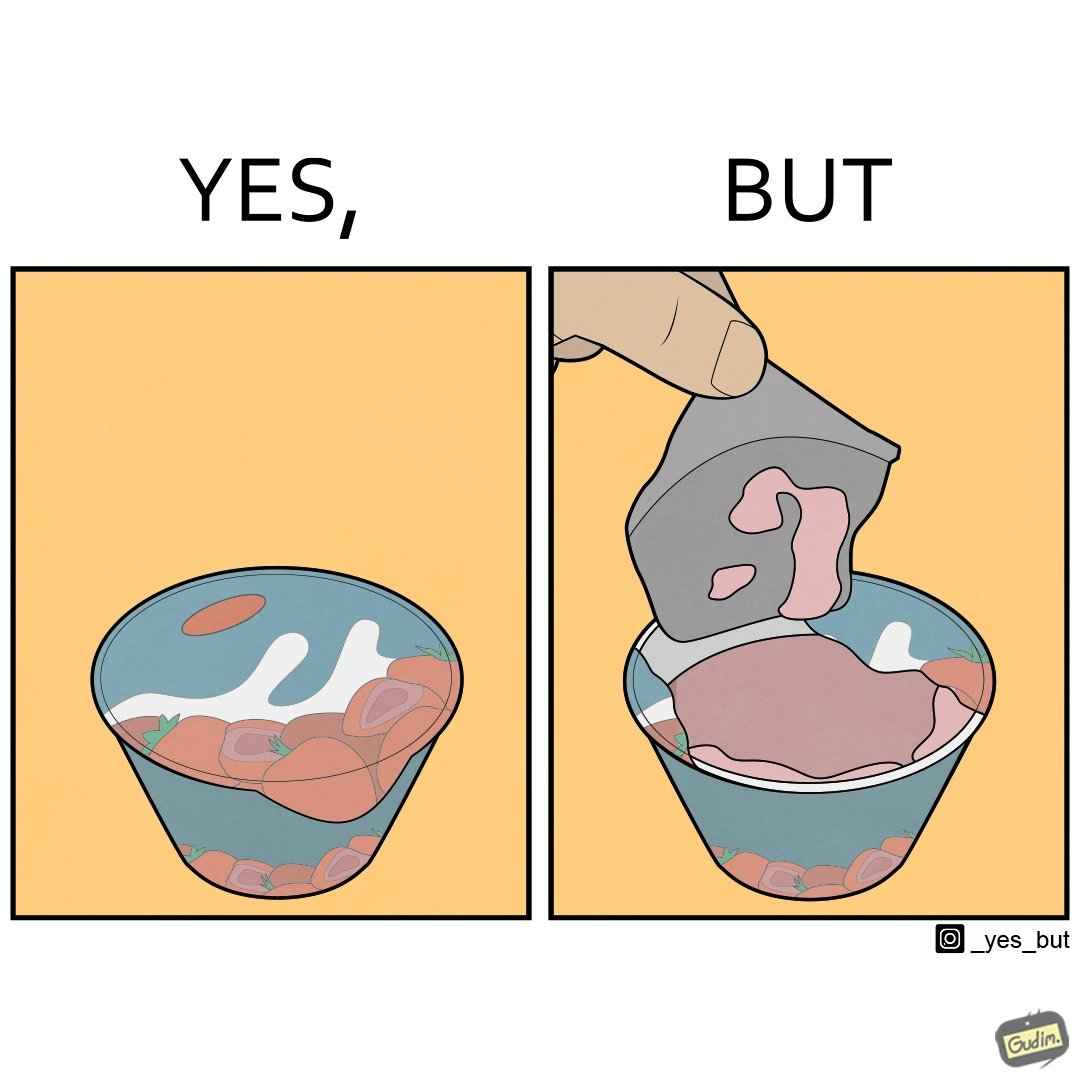Describe the contrast between the left and right parts of this image. In the left part of the image: It is a beautiful food package In the right part of the image: It is a food package that has been torn open 